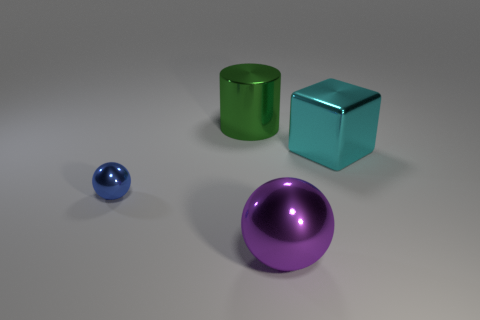Is there anything else that has the same size as the blue object?
Give a very brief answer. No. Is there anything else that has the same shape as the cyan metal object?
Keep it short and to the point. No. There is a large thing that is both in front of the metal cylinder and behind the purple shiny object; what is its shape?
Provide a succinct answer. Cube. There is a shiny sphere that is left of the large metal cylinder; are there any metal things on the right side of it?
Ensure brevity in your answer.  Yes. What number of other objects are the same material as the large block?
Ensure brevity in your answer.  3. Is the shape of the big thing to the left of the purple sphere the same as the object to the left of the cylinder?
Offer a very short reply. No. What size is the sphere that is on the left side of the big shiny object on the left side of the big metallic thing that is in front of the small object?
Offer a terse response. Small. What shape is the purple shiny thing that is the same size as the green metal thing?
Provide a succinct answer. Sphere. How many small things are either metallic balls or cyan matte balls?
Provide a short and direct response. 1. Is there a green metallic thing that is left of the metallic ball right of the large metal thing behind the large cyan cube?
Provide a succinct answer. Yes. 